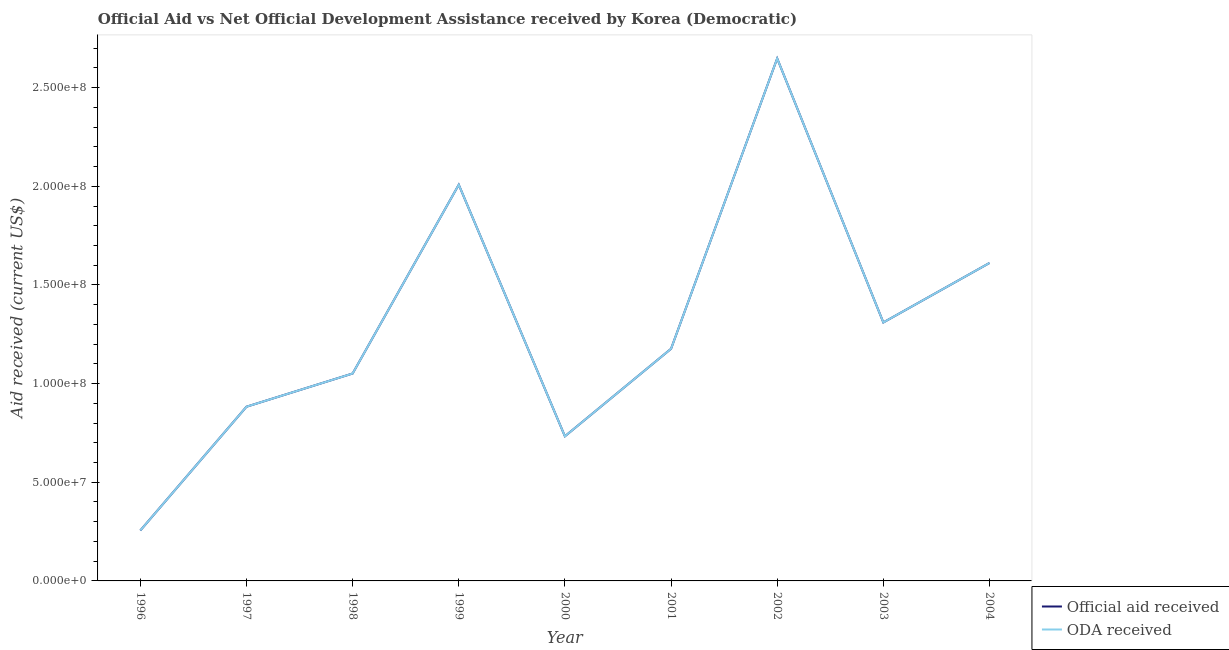How many different coloured lines are there?
Your answer should be compact. 2. Is the number of lines equal to the number of legend labels?
Provide a succinct answer. Yes. What is the official aid received in 1999?
Keep it short and to the point. 2.01e+08. Across all years, what is the maximum oda received?
Your response must be concise. 2.65e+08. Across all years, what is the minimum official aid received?
Ensure brevity in your answer.  2.56e+07. What is the total official aid received in the graph?
Give a very brief answer. 1.17e+09. What is the difference between the oda received in 1997 and that in 2003?
Offer a very short reply. -4.27e+07. What is the difference between the oda received in 2004 and the official aid received in 2001?
Provide a succinct answer. 4.35e+07. What is the average official aid received per year?
Make the answer very short. 1.30e+08. In how many years, is the oda received greater than 150000000 US$?
Provide a succinct answer. 3. What is the ratio of the oda received in 2000 to that in 2001?
Provide a short and direct response. 0.62. Is the official aid received in 1999 less than that in 2001?
Your response must be concise. No. What is the difference between the highest and the second highest oda received?
Ensure brevity in your answer.  6.40e+07. What is the difference between the highest and the lowest oda received?
Offer a very short reply. 2.39e+08. In how many years, is the official aid received greater than the average official aid received taken over all years?
Your answer should be compact. 4. Does the official aid received monotonically increase over the years?
Your answer should be compact. No. Is the oda received strictly greater than the official aid received over the years?
Offer a very short reply. No. Is the official aid received strictly less than the oda received over the years?
Your answer should be compact. No. How many lines are there?
Your response must be concise. 2. How many years are there in the graph?
Your response must be concise. 9. What is the difference between two consecutive major ticks on the Y-axis?
Make the answer very short. 5.00e+07. Does the graph contain any zero values?
Offer a terse response. No. Where does the legend appear in the graph?
Give a very brief answer. Bottom right. How many legend labels are there?
Give a very brief answer. 2. What is the title of the graph?
Offer a very short reply. Official Aid vs Net Official Development Assistance received by Korea (Democratic) . What is the label or title of the X-axis?
Provide a short and direct response. Year. What is the label or title of the Y-axis?
Make the answer very short. Aid received (current US$). What is the Aid received (current US$) of Official aid received in 1996?
Keep it short and to the point. 2.56e+07. What is the Aid received (current US$) in ODA received in 1996?
Your response must be concise. 2.56e+07. What is the Aid received (current US$) in Official aid received in 1997?
Provide a succinct answer. 8.83e+07. What is the Aid received (current US$) of ODA received in 1997?
Give a very brief answer. 8.83e+07. What is the Aid received (current US$) in Official aid received in 1998?
Your response must be concise. 1.05e+08. What is the Aid received (current US$) of ODA received in 1998?
Offer a very short reply. 1.05e+08. What is the Aid received (current US$) of Official aid received in 1999?
Your response must be concise. 2.01e+08. What is the Aid received (current US$) of ODA received in 1999?
Your response must be concise. 2.01e+08. What is the Aid received (current US$) of Official aid received in 2000?
Give a very brief answer. 7.33e+07. What is the Aid received (current US$) in ODA received in 2000?
Your answer should be compact. 7.33e+07. What is the Aid received (current US$) of Official aid received in 2001?
Offer a very short reply. 1.18e+08. What is the Aid received (current US$) in ODA received in 2001?
Provide a short and direct response. 1.18e+08. What is the Aid received (current US$) of Official aid received in 2002?
Your answer should be very brief. 2.65e+08. What is the Aid received (current US$) in ODA received in 2002?
Provide a succinct answer. 2.65e+08. What is the Aid received (current US$) of Official aid received in 2003?
Provide a succinct answer. 1.31e+08. What is the Aid received (current US$) of ODA received in 2003?
Make the answer very short. 1.31e+08. What is the Aid received (current US$) in Official aid received in 2004?
Give a very brief answer. 1.61e+08. What is the Aid received (current US$) in ODA received in 2004?
Offer a very short reply. 1.61e+08. Across all years, what is the maximum Aid received (current US$) in Official aid received?
Offer a terse response. 2.65e+08. Across all years, what is the maximum Aid received (current US$) of ODA received?
Your answer should be compact. 2.65e+08. Across all years, what is the minimum Aid received (current US$) in Official aid received?
Your answer should be compact. 2.56e+07. Across all years, what is the minimum Aid received (current US$) in ODA received?
Your answer should be very brief. 2.56e+07. What is the total Aid received (current US$) in Official aid received in the graph?
Your answer should be compact. 1.17e+09. What is the total Aid received (current US$) in ODA received in the graph?
Offer a terse response. 1.17e+09. What is the difference between the Aid received (current US$) of Official aid received in 1996 and that in 1997?
Provide a short and direct response. -6.27e+07. What is the difference between the Aid received (current US$) in ODA received in 1996 and that in 1997?
Offer a terse response. -6.27e+07. What is the difference between the Aid received (current US$) in Official aid received in 1996 and that in 1998?
Your answer should be very brief. -7.95e+07. What is the difference between the Aid received (current US$) of ODA received in 1996 and that in 1998?
Give a very brief answer. -7.95e+07. What is the difference between the Aid received (current US$) in Official aid received in 1996 and that in 1999?
Your answer should be very brief. -1.75e+08. What is the difference between the Aid received (current US$) in ODA received in 1996 and that in 1999?
Provide a succinct answer. -1.75e+08. What is the difference between the Aid received (current US$) of Official aid received in 1996 and that in 2000?
Provide a short and direct response. -4.77e+07. What is the difference between the Aid received (current US$) in ODA received in 1996 and that in 2000?
Ensure brevity in your answer.  -4.77e+07. What is the difference between the Aid received (current US$) in Official aid received in 1996 and that in 2001?
Your answer should be compact. -9.21e+07. What is the difference between the Aid received (current US$) in ODA received in 1996 and that in 2001?
Your response must be concise. -9.21e+07. What is the difference between the Aid received (current US$) in Official aid received in 1996 and that in 2002?
Keep it short and to the point. -2.39e+08. What is the difference between the Aid received (current US$) in ODA received in 1996 and that in 2002?
Keep it short and to the point. -2.39e+08. What is the difference between the Aid received (current US$) in Official aid received in 1996 and that in 2003?
Offer a terse response. -1.05e+08. What is the difference between the Aid received (current US$) in ODA received in 1996 and that in 2003?
Provide a succinct answer. -1.05e+08. What is the difference between the Aid received (current US$) of Official aid received in 1996 and that in 2004?
Keep it short and to the point. -1.36e+08. What is the difference between the Aid received (current US$) in ODA received in 1996 and that in 2004?
Provide a short and direct response. -1.36e+08. What is the difference between the Aid received (current US$) in Official aid received in 1997 and that in 1998?
Ensure brevity in your answer.  -1.68e+07. What is the difference between the Aid received (current US$) in ODA received in 1997 and that in 1998?
Your answer should be compact. -1.68e+07. What is the difference between the Aid received (current US$) in Official aid received in 1997 and that in 1999?
Your answer should be compact. -1.12e+08. What is the difference between the Aid received (current US$) of ODA received in 1997 and that in 1999?
Ensure brevity in your answer.  -1.12e+08. What is the difference between the Aid received (current US$) in Official aid received in 1997 and that in 2000?
Your answer should be compact. 1.50e+07. What is the difference between the Aid received (current US$) in ODA received in 1997 and that in 2000?
Provide a short and direct response. 1.50e+07. What is the difference between the Aid received (current US$) of Official aid received in 1997 and that in 2001?
Keep it short and to the point. -2.94e+07. What is the difference between the Aid received (current US$) of ODA received in 1997 and that in 2001?
Give a very brief answer. -2.94e+07. What is the difference between the Aid received (current US$) of Official aid received in 1997 and that in 2002?
Make the answer very short. -1.76e+08. What is the difference between the Aid received (current US$) of ODA received in 1997 and that in 2002?
Your answer should be very brief. -1.76e+08. What is the difference between the Aid received (current US$) of Official aid received in 1997 and that in 2003?
Your answer should be very brief. -4.27e+07. What is the difference between the Aid received (current US$) in ODA received in 1997 and that in 2003?
Provide a short and direct response. -4.27e+07. What is the difference between the Aid received (current US$) of Official aid received in 1997 and that in 2004?
Your answer should be compact. -7.28e+07. What is the difference between the Aid received (current US$) in ODA received in 1997 and that in 2004?
Offer a terse response. -7.28e+07. What is the difference between the Aid received (current US$) of Official aid received in 1998 and that in 1999?
Your response must be concise. -9.57e+07. What is the difference between the Aid received (current US$) of ODA received in 1998 and that in 1999?
Provide a short and direct response. -9.57e+07. What is the difference between the Aid received (current US$) in Official aid received in 1998 and that in 2000?
Offer a terse response. 3.18e+07. What is the difference between the Aid received (current US$) in ODA received in 1998 and that in 2000?
Your answer should be very brief. 3.18e+07. What is the difference between the Aid received (current US$) in Official aid received in 1998 and that in 2001?
Keep it short and to the point. -1.25e+07. What is the difference between the Aid received (current US$) in ODA received in 1998 and that in 2001?
Provide a succinct answer. -1.25e+07. What is the difference between the Aid received (current US$) of Official aid received in 1998 and that in 2002?
Give a very brief answer. -1.60e+08. What is the difference between the Aid received (current US$) in ODA received in 1998 and that in 2002?
Your answer should be very brief. -1.60e+08. What is the difference between the Aid received (current US$) of Official aid received in 1998 and that in 2003?
Provide a succinct answer. -2.59e+07. What is the difference between the Aid received (current US$) of ODA received in 1998 and that in 2003?
Provide a short and direct response. -2.59e+07. What is the difference between the Aid received (current US$) in Official aid received in 1998 and that in 2004?
Your response must be concise. -5.60e+07. What is the difference between the Aid received (current US$) of ODA received in 1998 and that in 2004?
Provide a short and direct response. -5.60e+07. What is the difference between the Aid received (current US$) in Official aid received in 1999 and that in 2000?
Offer a terse response. 1.27e+08. What is the difference between the Aid received (current US$) of ODA received in 1999 and that in 2000?
Your answer should be compact. 1.27e+08. What is the difference between the Aid received (current US$) in Official aid received in 1999 and that in 2001?
Offer a terse response. 8.31e+07. What is the difference between the Aid received (current US$) in ODA received in 1999 and that in 2001?
Ensure brevity in your answer.  8.31e+07. What is the difference between the Aid received (current US$) of Official aid received in 1999 and that in 2002?
Your response must be concise. -6.40e+07. What is the difference between the Aid received (current US$) in ODA received in 1999 and that in 2002?
Offer a terse response. -6.40e+07. What is the difference between the Aid received (current US$) in Official aid received in 1999 and that in 2003?
Provide a short and direct response. 6.98e+07. What is the difference between the Aid received (current US$) in ODA received in 1999 and that in 2003?
Keep it short and to the point. 6.98e+07. What is the difference between the Aid received (current US$) of Official aid received in 1999 and that in 2004?
Your answer should be very brief. 3.96e+07. What is the difference between the Aid received (current US$) in ODA received in 1999 and that in 2004?
Keep it short and to the point. 3.96e+07. What is the difference between the Aid received (current US$) in Official aid received in 2000 and that in 2001?
Make the answer very short. -4.43e+07. What is the difference between the Aid received (current US$) of ODA received in 2000 and that in 2001?
Offer a very short reply. -4.43e+07. What is the difference between the Aid received (current US$) in Official aid received in 2000 and that in 2002?
Provide a succinct answer. -1.91e+08. What is the difference between the Aid received (current US$) of ODA received in 2000 and that in 2002?
Your answer should be very brief. -1.91e+08. What is the difference between the Aid received (current US$) of Official aid received in 2000 and that in 2003?
Offer a very short reply. -5.77e+07. What is the difference between the Aid received (current US$) of ODA received in 2000 and that in 2003?
Give a very brief answer. -5.77e+07. What is the difference between the Aid received (current US$) in Official aid received in 2000 and that in 2004?
Give a very brief answer. -8.78e+07. What is the difference between the Aid received (current US$) of ODA received in 2000 and that in 2004?
Your response must be concise. -8.78e+07. What is the difference between the Aid received (current US$) in Official aid received in 2001 and that in 2002?
Your response must be concise. -1.47e+08. What is the difference between the Aid received (current US$) of ODA received in 2001 and that in 2002?
Provide a succinct answer. -1.47e+08. What is the difference between the Aid received (current US$) in Official aid received in 2001 and that in 2003?
Your response must be concise. -1.34e+07. What is the difference between the Aid received (current US$) of ODA received in 2001 and that in 2003?
Your response must be concise. -1.34e+07. What is the difference between the Aid received (current US$) in Official aid received in 2001 and that in 2004?
Ensure brevity in your answer.  -4.35e+07. What is the difference between the Aid received (current US$) of ODA received in 2001 and that in 2004?
Your answer should be very brief. -4.35e+07. What is the difference between the Aid received (current US$) of Official aid received in 2002 and that in 2003?
Your response must be concise. 1.34e+08. What is the difference between the Aid received (current US$) of ODA received in 2002 and that in 2003?
Offer a very short reply. 1.34e+08. What is the difference between the Aid received (current US$) in Official aid received in 2002 and that in 2004?
Offer a very short reply. 1.04e+08. What is the difference between the Aid received (current US$) in ODA received in 2002 and that in 2004?
Give a very brief answer. 1.04e+08. What is the difference between the Aid received (current US$) in Official aid received in 2003 and that in 2004?
Keep it short and to the point. -3.01e+07. What is the difference between the Aid received (current US$) in ODA received in 2003 and that in 2004?
Offer a terse response. -3.01e+07. What is the difference between the Aid received (current US$) of Official aid received in 1996 and the Aid received (current US$) of ODA received in 1997?
Provide a short and direct response. -6.27e+07. What is the difference between the Aid received (current US$) in Official aid received in 1996 and the Aid received (current US$) in ODA received in 1998?
Provide a succinct answer. -7.95e+07. What is the difference between the Aid received (current US$) in Official aid received in 1996 and the Aid received (current US$) in ODA received in 1999?
Provide a short and direct response. -1.75e+08. What is the difference between the Aid received (current US$) in Official aid received in 1996 and the Aid received (current US$) in ODA received in 2000?
Give a very brief answer. -4.77e+07. What is the difference between the Aid received (current US$) in Official aid received in 1996 and the Aid received (current US$) in ODA received in 2001?
Offer a terse response. -9.21e+07. What is the difference between the Aid received (current US$) in Official aid received in 1996 and the Aid received (current US$) in ODA received in 2002?
Offer a very short reply. -2.39e+08. What is the difference between the Aid received (current US$) of Official aid received in 1996 and the Aid received (current US$) of ODA received in 2003?
Keep it short and to the point. -1.05e+08. What is the difference between the Aid received (current US$) in Official aid received in 1996 and the Aid received (current US$) in ODA received in 2004?
Offer a terse response. -1.36e+08. What is the difference between the Aid received (current US$) in Official aid received in 1997 and the Aid received (current US$) in ODA received in 1998?
Provide a succinct answer. -1.68e+07. What is the difference between the Aid received (current US$) of Official aid received in 1997 and the Aid received (current US$) of ODA received in 1999?
Your answer should be very brief. -1.12e+08. What is the difference between the Aid received (current US$) of Official aid received in 1997 and the Aid received (current US$) of ODA received in 2000?
Keep it short and to the point. 1.50e+07. What is the difference between the Aid received (current US$) in Official aid received in 1997 and the Aid received (current US$) in ODA received in 2001?
Your response must be concise. -2.94e+07. What is the difference between the Aid received (current US$) of Official aid received in 1997 and the Aid received (current US$) of ODA received in 2002?
Offer a very short reply. -1.76e+08. What is the difference between the Aid received (current US$) in Official aid received in 1997 and the Aid received (current US$) in ODA received in 2003?
Offer a very short reply. -4.27e+07. What is the difference between the Aid received (current US$) in Official aid received in 1997 and the Aid received (current US$) in ODA received in 2004?
Give a very brief answer. -7.28e+07. What is the difference between the Aid received (current US$) in Official aid received in 1998 and the Aid received (current US$) in ODA received in 1999?
Provide a succinct answer. -9.57e+07. What is the difference between the Aid received (current US$) of Official aid received in 1998 and the Aid received (current US$) of ODA received in 2000?
Your response must be concise. 3.18e+07. What is the difference between the Aid received (current US$) in Official aid received in 1998 and the Aid received (current US$) in ODA received in 2001?
Offer a very short reply. -1.25e+07. What is the difference between the Aid received (current US$) of Official aid received in 1998 and the Aid received (current US$) of ODA received in 2002?
Provide a short and direct response. -1.60e+08. What is the difference between the Aid received (current US$) of Official aid received in 1998 and the Aid received (current US$) of ODA received in 2003?
Give a very brief answer. -2.59e+07. What is the difference between the Aid received (current US$) in Official aid received in 1998 and the Aid received (current US$) in ODA received in 2004?
Ensure brevity in your answer.  -5.60e+07. What is the difference between the Aid received (current US$) of Official aid received in 1999 and the Aid received (current US$) of ODA received in 2000?
Your answer should be very brief. 1.27e+08. What is the difference between the Aid received (current US$) of Official aid received in 1999 and the Aid received (current US$) of ODA received in 2001?
Your response must be concise. 8.31e+07. What is the difference between the Aid received (current US$) in Official aid received in 1999 and the Aid received (current US$) in ODA received in 2002?
Keep it short and to the point. -6.40e+07. What is the difference between the Aid received (current US$) of Official aid received in 1999 and the Aid received (current US$) of ODA received in 2003?
Offer a terse response. 6.98e+07. What is the difference between the Aid received (current US$) in Official aid received in 1999 and the Aid received (current US$) in ODA received in 2004?
Ensure brevity in your answer.  3.96e+07. What is the difference between the Aid received (current US$) of Official aid received in 2000 and the Aid received (current US$) of ODA received in 2001?
Provide a succinct answer. -4.43e+07. What is the difference between the Aid received (current US$) in Official aid received in 2000 and the Aid received (current US$) in ODA received in 2002?
Your answer should be very brief. -1.91e+08. What is the difference between the Aid received (current US$) in Official aid received in 2000 and the Aid received (current US$) in ODA received in 2003?
Keep it short and to the point. -5.77e+07. What is the difference between the Aid received (current US$) in Official aid received in 2000 and the Aid received (current US$) in ODA received in 2004?
Make the answer very short. -8.78e+07. What is the difference between the Aid received (current US$) of Official aid received in 2001 and the Aid received (current US$) of ODA received in 2002?
Offer a terse response. -1.47e+08. What is the difference between the Aid received (current US$) of Official aid received in 2001 and the Aid received (current US$) of ODA received in 2003?
Offer a very short reply. -1.34e+07. What is the difference between the Aid received (current US$) of Official aid received in 2001 and the Aid received (current US$) of ODA received in 2004?
Provide a short and direct response. -4.35e+07. What is the difference between the Aid received (current US$) of Official aid received in 2002 and the Aid received (current US$) of ODA received in 2003?
Make the answer very short. 1.34e+08. What is the difference between the Aid received (current US$) of Official aid received in 2002 and the Aid received (current US$) of ODA received in 2004?
Your answer should be compact. 1.04e+08. What is the difference between the Aid received (current US$) in Official aid received in 2003 and the Aid received (current US$) in ODA received in 2004?
Make the answer very short. -3.01e+07. What is the average Aid received (current US$) of Official aid received per year?
Offer a terse response. 1.30e+08. What is the average Aid received (current US$) in ODA received per year?
Offer a very short reply. 1.30e+08. In the year 1996, what is the difference between the Aid received (current US$) of Official aid received and Aid received (current US$) of ODA received?
Provide a succinct answer. 0. In the year 2002, what is the difference between the Aid received (current US$) of Official aid received and Aid received (current US$) of ODA received?
Keep it short and to the point. 0. What is the ratio of the Aid received (current US$) in Official aid received in 1996 to that in 1997?
Keep it short and to the point. 0.29. What is the ratio of the Aid received (current US$) in ODA received in 1996 to that in 1997?
Make the answer very short. 0.29. What is the ratio of the Aid received (current US$) in Official aid received in 1996 to that in 1998?
Your answer should be very brief. 0.24. What is the ratio of the Aid received (current US$) in ODA received in 1996 to that in 1998?
Provide a succinct answer. 0.24. What is the ratio of the Aid received (current US$) in Official aid received in 1996 to that in 1999?
Offer a terse response. 0.13. What is the ratio of the Aid received (current US$) in ODA received in 1996 to that in 1999?
Offer a very short reply. 0.13. What is the ratio of the Aid received (current US$) of Official aid received in 1996 to that in 2000?
Your response must be concise. 0.35. What is the ratio of the Aid received (current US$) of ODA received in 1996 to that in 2000?
Keep it short and to the point. 0.35. What is the ratio of the Aid received (current US$) in Official aid received in 1996 to that in 2001?
Make the answer very short. 0.22. What is the ratio of the Aid received (current US$) in ODA received in 1996 to that in 2001?
Keep it short and to the point. 0.22. What is the ratio of the Aid received (current US$) in Official aid received in 1996 to that in 2002?
Your answer should be very brief. 0.1. What is the ratio of the Aid received (current US$) in ODA received in 1996 to that in 2002?
Provide a succinct answer. 0.1. What is the ratio of the Aid received (current US$) of Official aid received in 1996 to that in 2003?
Provide a short and direct response. 0.2. What is the ratio of the Aid received (current US$) of ODA received in 1996 to that in 2003?
Your answer should be very brief. 0.2. What is the ratio of the Aid received (current US$) of Official aid received in 1996 to that in 2004?
Offer a terse response. 0.16. What is the ratio of the Aid received (current US$) in ODA received in 1996 to that in 2004?
Keep it short and to the point. 0.16. What is the ratio of the Aid received (current US$) in Official aid received in 1997 to that in 1998?
Your answer should be very brief. 0.84. What is the ratio of the Aid received (current US$) of ODA received in 1997 to that in 1998?
Your response must be concise. 0.84. What is the ratio of the Aid received (current US$) of Official aid received in 1997 to that in 1999?
Your answer should be compact. 0.44. What is the ratio of the Aid received (current US$) in ODA received in 1997 to that in 1999?
Keep it short and to the point. 0.44. What is the ratio of the Aid received (current US$) of Official aid received in 1997 to that in 2000?
Offer a terse response. 1.2. What is the ratio of the Aid received (current US$) of ODA received in 1997 to that in 2000?
Make the answer very short. 1.2. What is the ratio of the Aid received (current US$) in Official aid received in 1997 to that in 2001?
Make the answer very short. 0.75. What is the ratio of the Aid received (current US$) of ODA received in 1997 to that in 2001?
Your response must be concise. 0.75. What is the ratio of the Aid received (current US$) in Official aid received in 1997 to that in 2002?
Your response must be concise. 0.33. What is the ratio of the Aid received (current US$) of ODA received in 1997 to that in 2002?
Keep it short and to the point. 0.33. What is the ratio of the Aid received (current US$) of Official aid received in 1997 to that in 2003?
Provide a succinct answer. 0.67. What is the ratio of the Aid received (current US$) in ODA received in 1997 to that in 2003?
Your answer should be very brief. 0.67. What is the ratio of the Aid received (current US$) in Official aid received in 1997 to that in 2004?
Offer a very short reply. 0.55. What is the ratio of the Aid received (current US$) of ODA received in 1997 to that in 2004?
Give a very brief answer. 0.55. What is the ratio of the Aid received (current US$) of Official aid received in 1998 to that in 1999?
Ensure brevity in your answer.  0.52. What is the ratio of the Aid received (current US$) of ODA received in 1998 to that in 1999?
Give a very brief answer. 0.52. What is the ratio of the Aid received (current US$) in Official aid received in 1998 to that in 2000?
Keep it short and to the point. 1.43. What is the ratio of the Aid received (current US$) of ODA received in 1998 to that in 2000?
Keep it short and to the point. 1.43. What is the ratio of the Aid received (current US$) in Official aid received in 1998 to that in 2001?
Make the answer very short. 0.89. What is the ratio of the Aid received (current US$) in ODA received in 1998 to that in 2001?
Provide a succinct answer. 0.89. What is the ratio of the Aid received (current US$) of Official aid received in 1998 to that in 2002?
Offer a terse response. 0.4. What is the ratio of the Aid received (current US$) of ODA received in 1998 to that in 2002?
Make the answer very short. 0.4. What is the ratio of the Aid received (current US$) of Official aid received in 1998 to that in 2003?
Give a very brief answer. 0.8. What is the ratio of the Aid received (current US$) of ODA received in 1998 to that in 2003?
Offer a very short reply. 0.8. What is the ratio of the Aid received (current US$) of Official aid received in 1998 to that in 2004?
Give a very brief answer. 0.65. What is the ratio of the Aid received (current US$) of ODA received in 1998 to that in 2004?
Offer a terse response. 0.65. What is the ratio of the Aid received (current US$) in Official aid received in 1999 to that in 2000?
Provide a short and direct response. 2.74. What is the ratio of the Aid received (current US$) in ODA received in 1999 to that in 2000?
Your response must be concise. 2.74. What is the ratio of the Aid received (current US$) of Official aid received in 1999 to that in 2001?
Your answer should be compact. 1.71. What is the ratio of the Aid received (current US$) of ODA received in 1999 to that in 2001?
Offer a very short reply. 1.71. What is the ratio of the Aid received (current US$) in Official aid received in 1999 to that in 2002?
Provide a succinct answer. 0.76. What is the ratio of the Aid received (current US$) in ODA received in 1999 to that in 2002?
Make the answer very short. 0.76. What is the ratio of the Aid received (current US$) of Official aid received in 1999 to that in 2003?
Provide a short and direct response. 1.53. What is the ratio of the Aid received (current US$) of ODA received in 1999 to that in 2003?
Provide a short and direct response. 1.53. What is the ratio of the Aid received (current US$) in Official aid received in 1999 to that in 2004?
Provide a short and direct response. 1.25. What is the ratio of the Aid received (current US$) in ODA received in 1999 to that in 2004?
Make the answer very short. 1.25. What is the ratio of the Aid received (current US$) in Official aid received in 2000 to that in 2001?
Your answer should be compact. 0.62. What is the ratio of the Aid received (current US$) of ODA received in 2000 to that in 2001?
Your response must be concise. 0.62. What is the ratio of the Aid received (current US$) of Official aid received in 2000 to that in 2002?
Offer a very short reply. 0.28. What is the ratio of the Aid received (current US$) in ODA received in 2000 to that in 2002?
Ensure brevity in your answer.  0.28. What is the ratio of the Aid received (current US$) of Official aid received in 2000 to that in 2003?
Give a very brief answer. 0.56. What is the ratio of the Aid received (current US$) of ODA received in 2000 to that in 2003?
Your answer should be compact. 0.56. What is the ratio of the Aid received (current US$) of Official aid received in 2000 to that in 2004?
Ensure brevity in your answer.  0.45. What is the ratio of the Aid received (current US$) in ODA received in 2000 to that in 2004?
Provide a succinct answer. 0.45. What is the ratio of the Aid received (current US$) of Official aid received in 2001 to that in 2002?
Provide a short and direct response. 0.44. What is the ratio of the Aid received (current US$) of ODA received in 2001 to that in 2002?
Offer a terse response. 0.44. What is the ratio of the Aid received (current US$) of Official aid received in 2001 to that in 2003?
Offer a terse response. 0.9. What is the ratio of the Aid received (current US$) of ODA received in 2001 to that in 2003?
Your answer should be compact. 0.9. What is the ratio of the Aid received (current US$) in Official aid received in 2001 to that in 2004?
Provide a short and direct response. 0.73. What is the ratio of the Aid received (current US$) in ODA received in 2001 to that in 2004?
Your answer should be very brief. 0.73. What is the ratio of the Aid received (current US$) of Official aid received in 2002 to that in 2003?
Provide a succinct answer. 2.02. What is the ratio of the Aid received (current US$) in ODA received in 2002 to that in 2003?
Give a very brief answer. 2.02. What is the ratio of the Aid received (current US$) in Official aid received in 2002 to that in 2004?
Make the answer very short. 1.64. What is the ratio of the Aid received (current US$) in ODA received in 2002 to that in 2004?
Provide a short and direct response. 1.64. What is the ratio of the Aid received (current US$) in Official aid received in 2003 to that in 2004?
Offer a terse response. 0.81. What is the ratio of the Aid received (current US$) in ODA received in 2003 to that in 2004?
Your answer should be very brief. 0.81. What is the difference between the highest and the second highest Aid received (current US$) in Official aid received?
Your answer should be very brief. 6.40e+07. What is the difference between the highest and the second highest Aid received (current US$) of ODA received?
Provide a succinct answer. 6.40e+07. What is the difference between the highest and the lowest Aid received (current US$) of Official aid received?
Provide a short and direct response. 2.39e+08. What is the difference between the highest and the lowest Aid received (current US$) in ODA received?
Provide a succinct answer. 2.39e+08. 